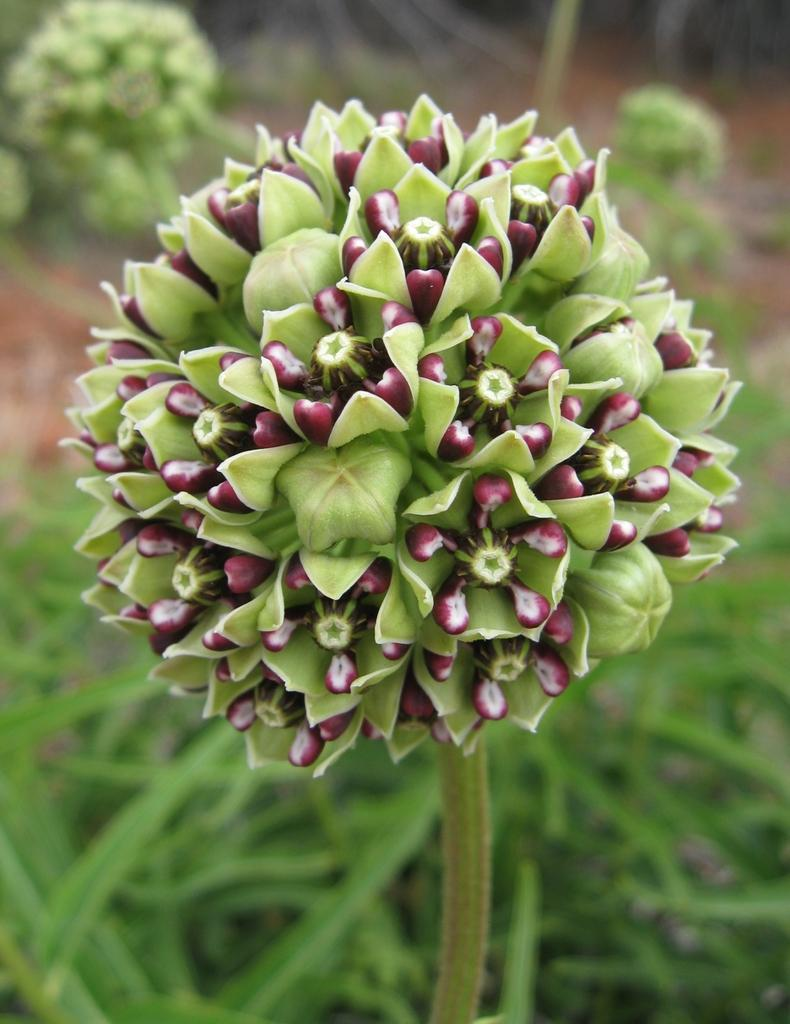What type of vegetation is visible in the image? There is grass and plants in the image. Can you describe the background of the image? The background of the image is slightly blurred. Is there an expert holding a gun in the image? There is no expert or gun present in the image; it features grass and plants with a slightly blurred background. Can you see a rabbit hopping through the grass in the image? There is no rabbit visible in the image; it only features grass and plants. 